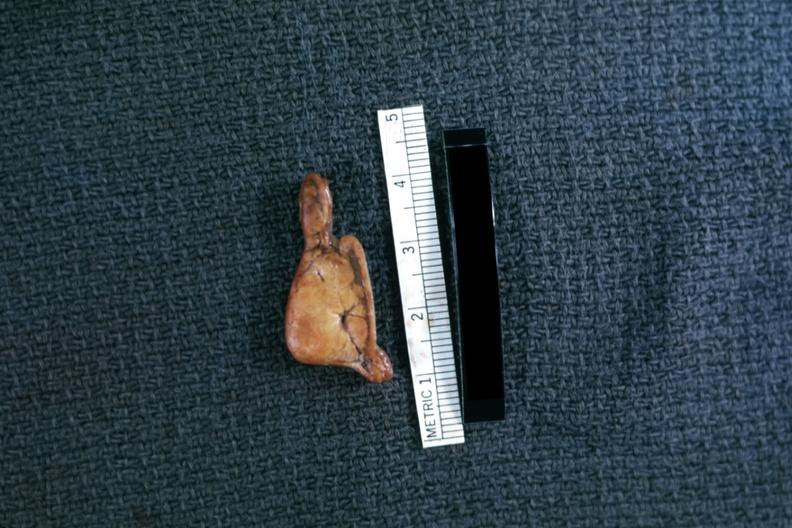s endocrine present?
Answer the question using a single word or phrase. Yes 